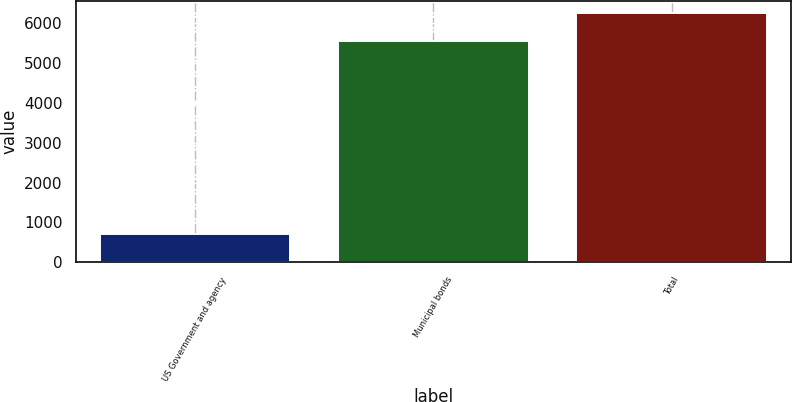Convert chart to OTSL. <chart><loc_0><loc_0><loc_500><loc_500><bar_chart><fcel>US Government and agency<fcel>Municipal bonds<fcel>Total<nl><fcel>704<fcel>5536<fcel>6240<nl></chart> 